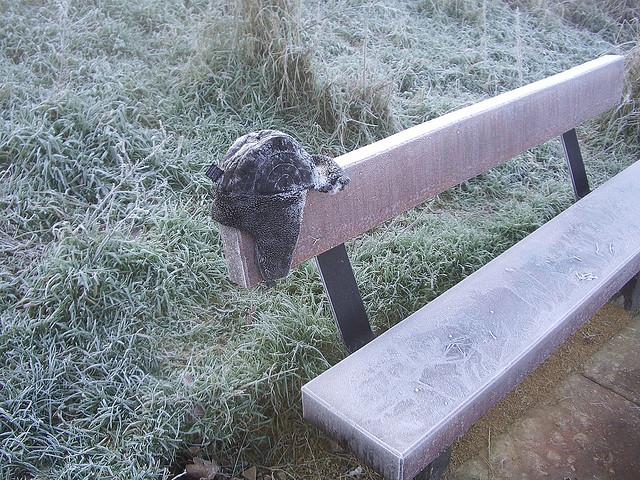What natural element is growing behind the bench?
Keep it brief. Grass. Are there people in the picture?
Quick response, please. No. Is there something dead on the back of the bench?
Be succinct. No. 